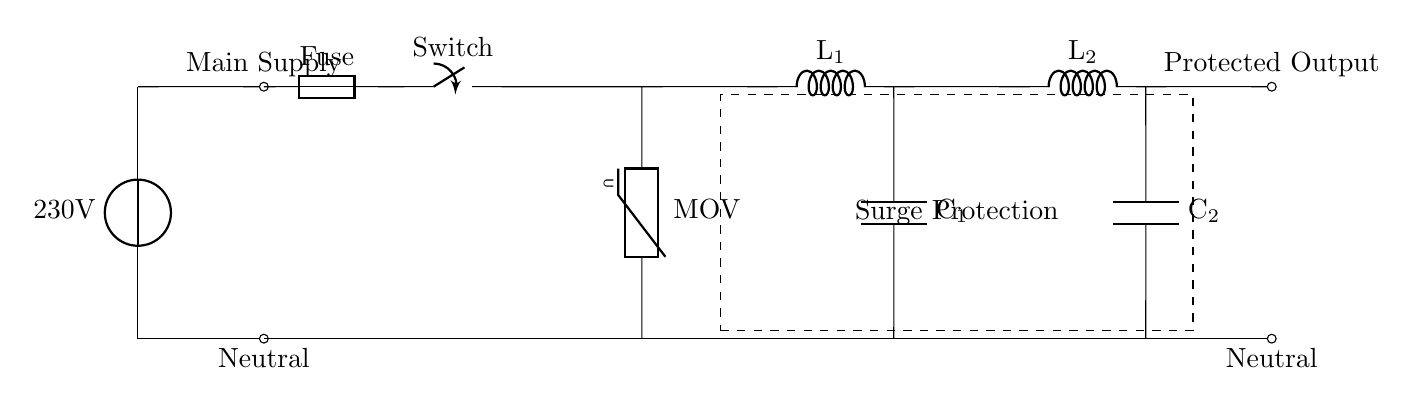What is the main supply voltage in this circuit? The main supply voltage is indicated near the voltage source symbol, which shows a value of 230 volts.
Answer: 230 volts What components are used for surge protection in this circuit? The components dedicated to surge protection are the metal oxide varistor (MOV) and the surrounding inductors and capacitors that form a protective network.
Answer: MOV, inductors, capacitors How many inductors are present in this circuit? There are two inductors shown in the diagram, indicated as L1 and L2, each connected to separate capacitors.
Answer: Two What role does the fuse play in this circuit? The fuse acts as a safety component that protects the circuit from overcurrent by breaking the connection if the current exceeds a specific limit.
Answer: Safety device What is the purpose of the capacitors in this surge protection circuit? The capacitors are used to filter out high-frequency noise and stabilize the voltage, providing additional protection against transients and surges.
Answer: Filtering and stabilizing voltage How does the varistor function in the context of this circuit? The varistor (MOV) protects sensitive equipment by clamping high voltage spikes and diverting excess energy away from the connected load when a surge occurs.
Answer: Clamps high voltage spikes What connections form the protected output in this circuit? The protected output is formed by connections from the inductors and capacitors to the output node, indicating that the output is filtered and protected.
Answer: Inductors and capacitors to output node 